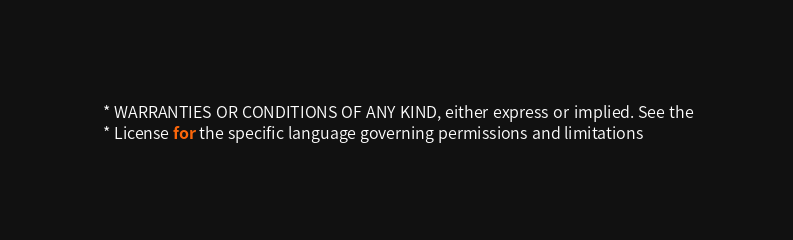Convert code to text. <code><loc_0><loc_0><loc_500><loc_500><_Java_> * WARRANTIES OR CONDITIONS OF ANY KIND, either express or implied. See the
 * License for the specific language governing permissions and limitations</code> 